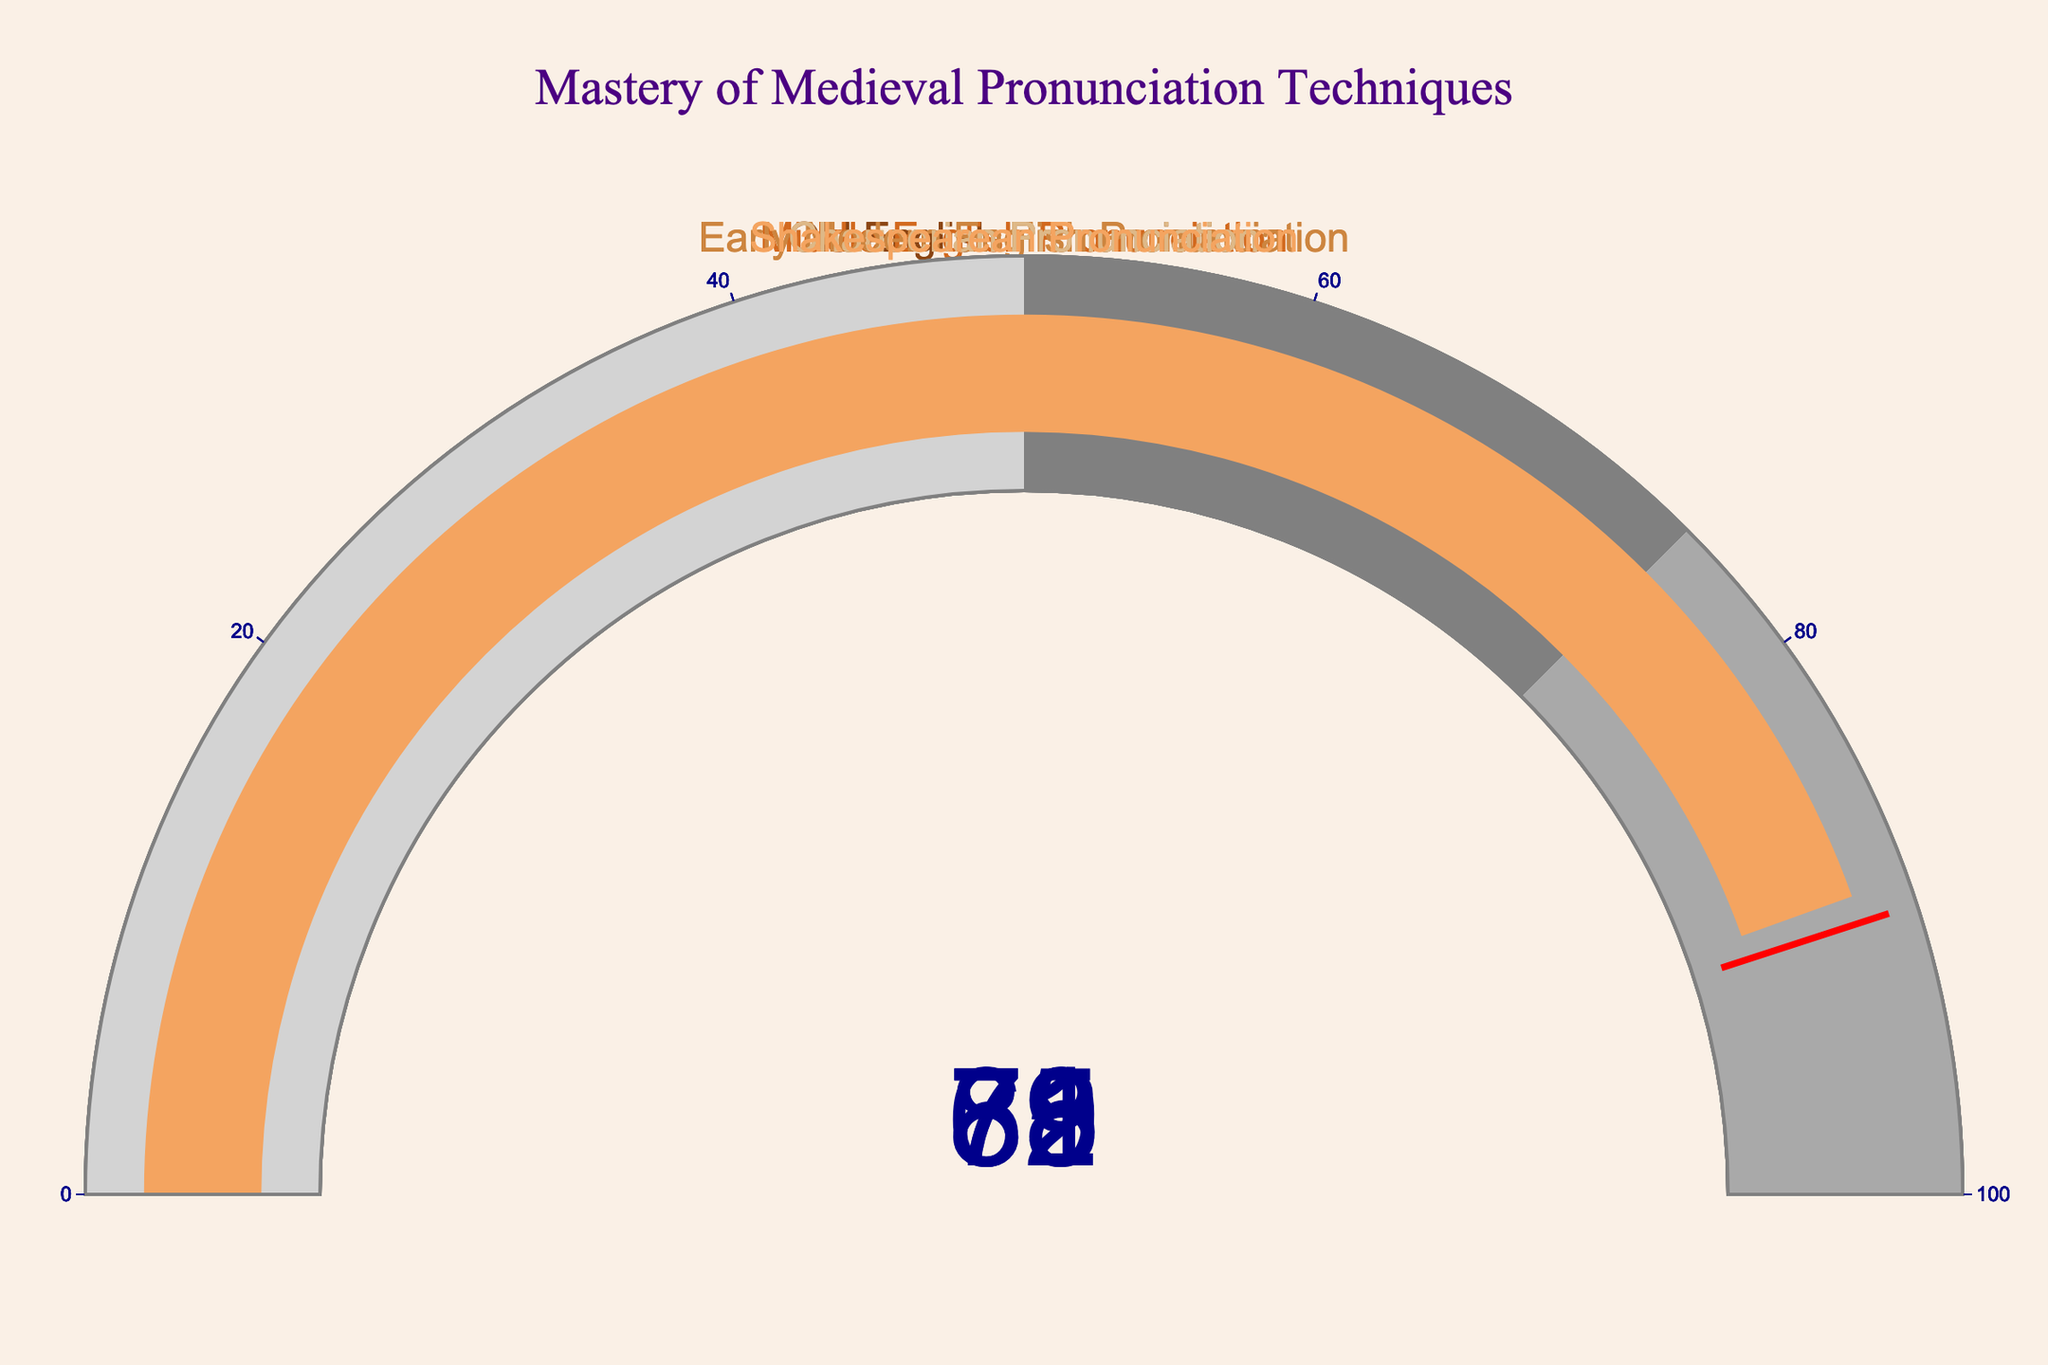What is the title of the figure? To find the title, look at the top of the figure where the largest text is found.
Answer: "Mastery of Medieval Pronunciation Techniques" How many categories of pronunciation techniques are presented in the figure? Check each gauge in the figure to count the different categories.
Answer: 5 Which category has the highest percentage of students mastering the pronunciation technique? Compare the percentages shown on each gauge to find the highest value.
Answer: Shakespearean Pronunciation What is the difference in mastery percentage between Chaucerian Pronunciation and Middle English Pronunciation? Subtract Chaucerian Pronunciation percentage from Middle English Pronunciation percentage: 78 - 71 = 7
Answer: 7 What is the average mastery percentage across all categories? Add all percentages and divide by the number of categories: (62 + 78 + 85 + 71 + 89) / 5 = 385 / 5 = 77
Answer: 77 Which two categories have the closest mastery percentages? Calculate the differences between each pair's percentages and find the smallest difference: 
Old English - Chaucerian: 62 - 71 = 9, Old English - Middle English: 62 - 78 = 16, Old English - Early Modern English: 62 - 85 = 23, Old English - Shakespearean: 62 - 89 = 27,
Chaucerian - Middle English: 71 - 78 = 7, Chaucerian - Early Modern English: 71 - 85 = 14, Chaucerian - Shakespearean: 71 - 89 = 18,
Middle English - Early Modern English: 78 - 85 = 7, Middle English - Shakespearean: 78 - 89 = 11,
Early Modern English - Shakespearean: 85 - 89 = 4. The closest pair is Early Modern English and Shakespearean with a difference of 4
Answer: Early Modern English and Shakespearean Explain the color scheme used in the figure. Each gauge uses a unique color for its bar, and the colors tend to range from brown to tan hues. There are also background color gradients on each gauge from light gray to dark gray.
Answer: Browns and tans with gradients from light to dark gray What is the range of the gauge indicators? The axis of each gauge indicator ranges from 0 to 100.
Answer: 0 to 100 Which category's mastery percentage falls within the 75-100 range but is not the highest? Identify the categories in the 75-100 range and exclude the highest: Middle English Pronunciation, Early Modern English Pronunciation, Chaucerian Pronunciation. Excluding the highest (Shakespearean Pronunciation at 89), the answer is Early Modern English Pronunciation at 85.
Answer: Early Modern English Pronunciation Which categories scored below 75% mastery? Identify and list the categories with percentages below 75: Old English Pronunciation at 62 and Chaucerian Pronunciation at 71.
Answer: Old English Pronunciation and Chaucerian Pronunciation 